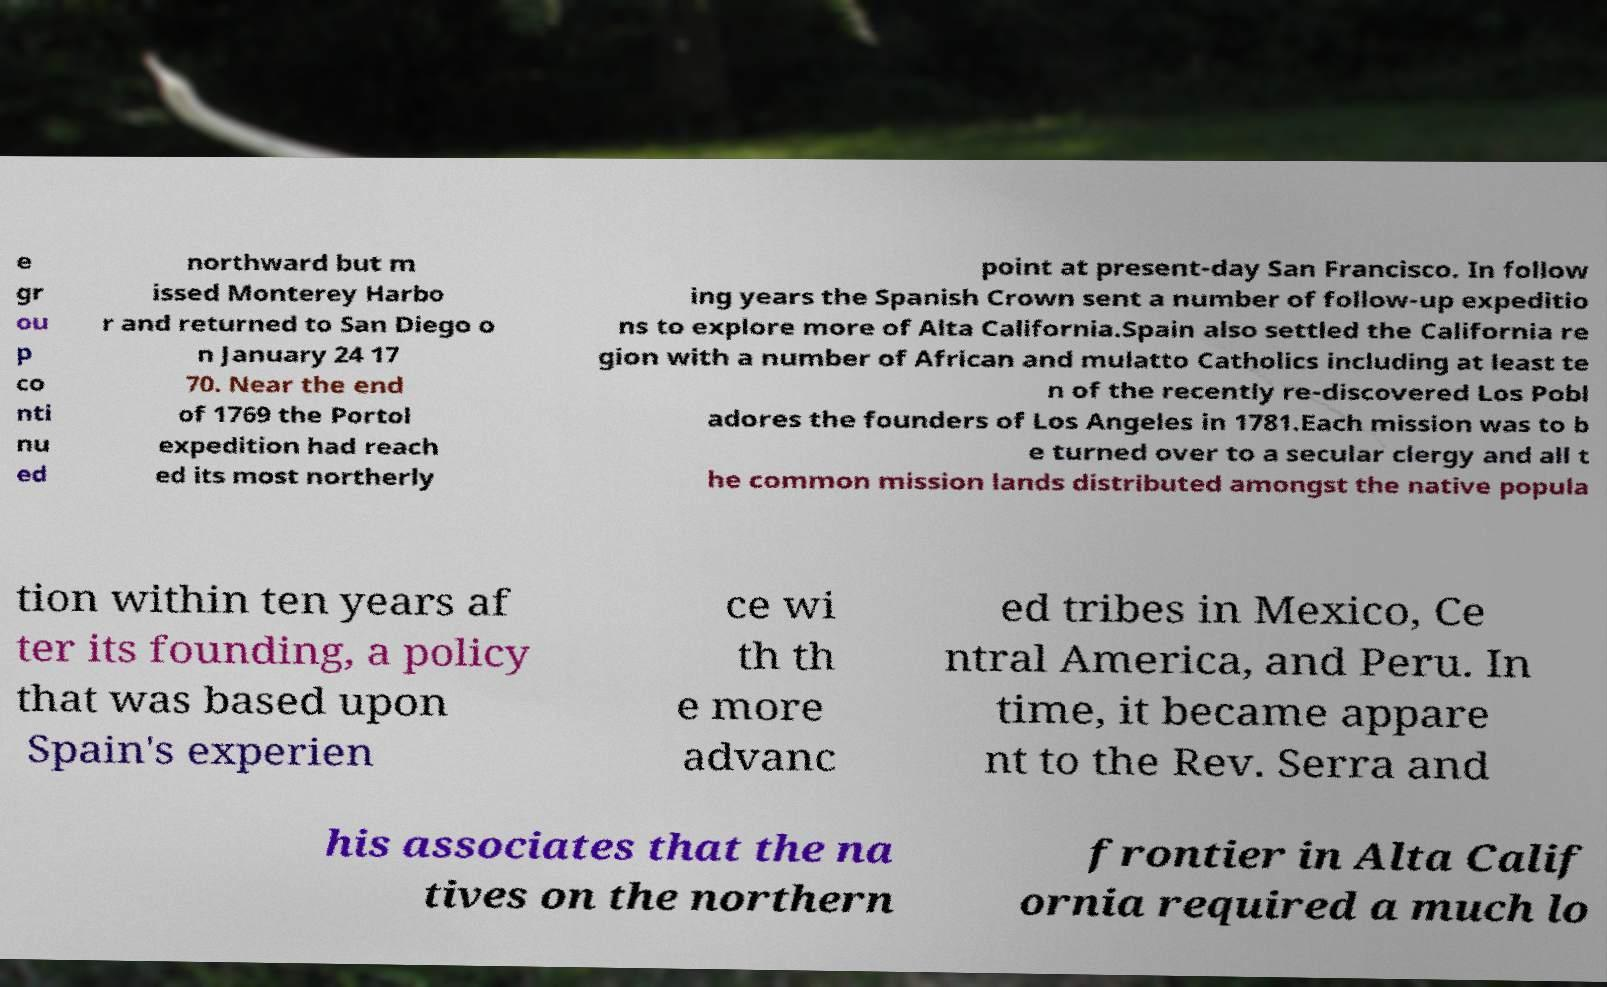I need the written content from this picture converted into text. Can you do that? e gr ou p co nti nu ed northward but m issed Monterey Harbo r and returned to San Diego o n January 24 17 70. Near the end of 1769 the Portol expedition had reach ed its most northerly point at present-day San Francisco. In follow ing years the Spanish Crown sent a number of follow-up expeditio ns to explore more of Alta California.Spain also settled the California re gion with a number of African and mulatto Catholics including at least te n of the recently re-discovered Los Pobl adores the founders of Los Angeles in 1781.Each mission was to b e turned over to a secular clergy and all t he common mission lands distributed amongst the native popula tion within ten years af ter its founding, a policy that was based upon Spain's experien ce wi th th e more advanc ed tribes in Mexico, Ce ntral America, and Peru. In time, it became appare nt to the Rev. Serra and his associates that the na tives on the northern frontier in Alta Calif ornia required a much lo 